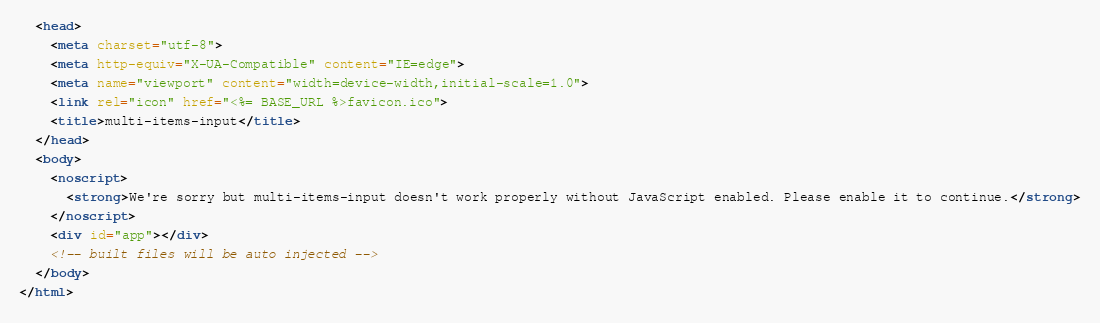<code> <loc_0><loc_0><loc_500><loc_500><_HTML_>  <head>
    <meta charset="utf-8">
    <meta http-equiv="X-UA-Compatible" content="IE=edge">
    <meta name="viewport" content="width=device-width,initial-scale=1.0">
    <link rel="icon" href="<%= BASE_URL %>favicon.ico">
    <title>multi-items-input</title>
  </head>
  <body>
    <noscript>
      <strong>We're sorry but multi-items-input doesn't work properly without JavaScript enabled. Please enable it to continue.</strong>
    </noscript>
    <div id="app"></div>
    <!-- built files will be auto injected -->
  </body>
</html>
</code> 